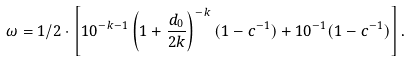Convert formula to latex. <formula><loc_0><loc_0><loc_500><loc_500>\omega = 1 / 2 \cdot \left [ 1 0 ^ { - k - 1 } \left ( 1 + \frac { d _ { 0 } } { 2 k } \right ) ^ { - k } ( 1 - c ^ { - 1 } ) + 1 0 ^ { - 1 } ( 1 - c ^ { - 1 } ) \right ] .</formula> 